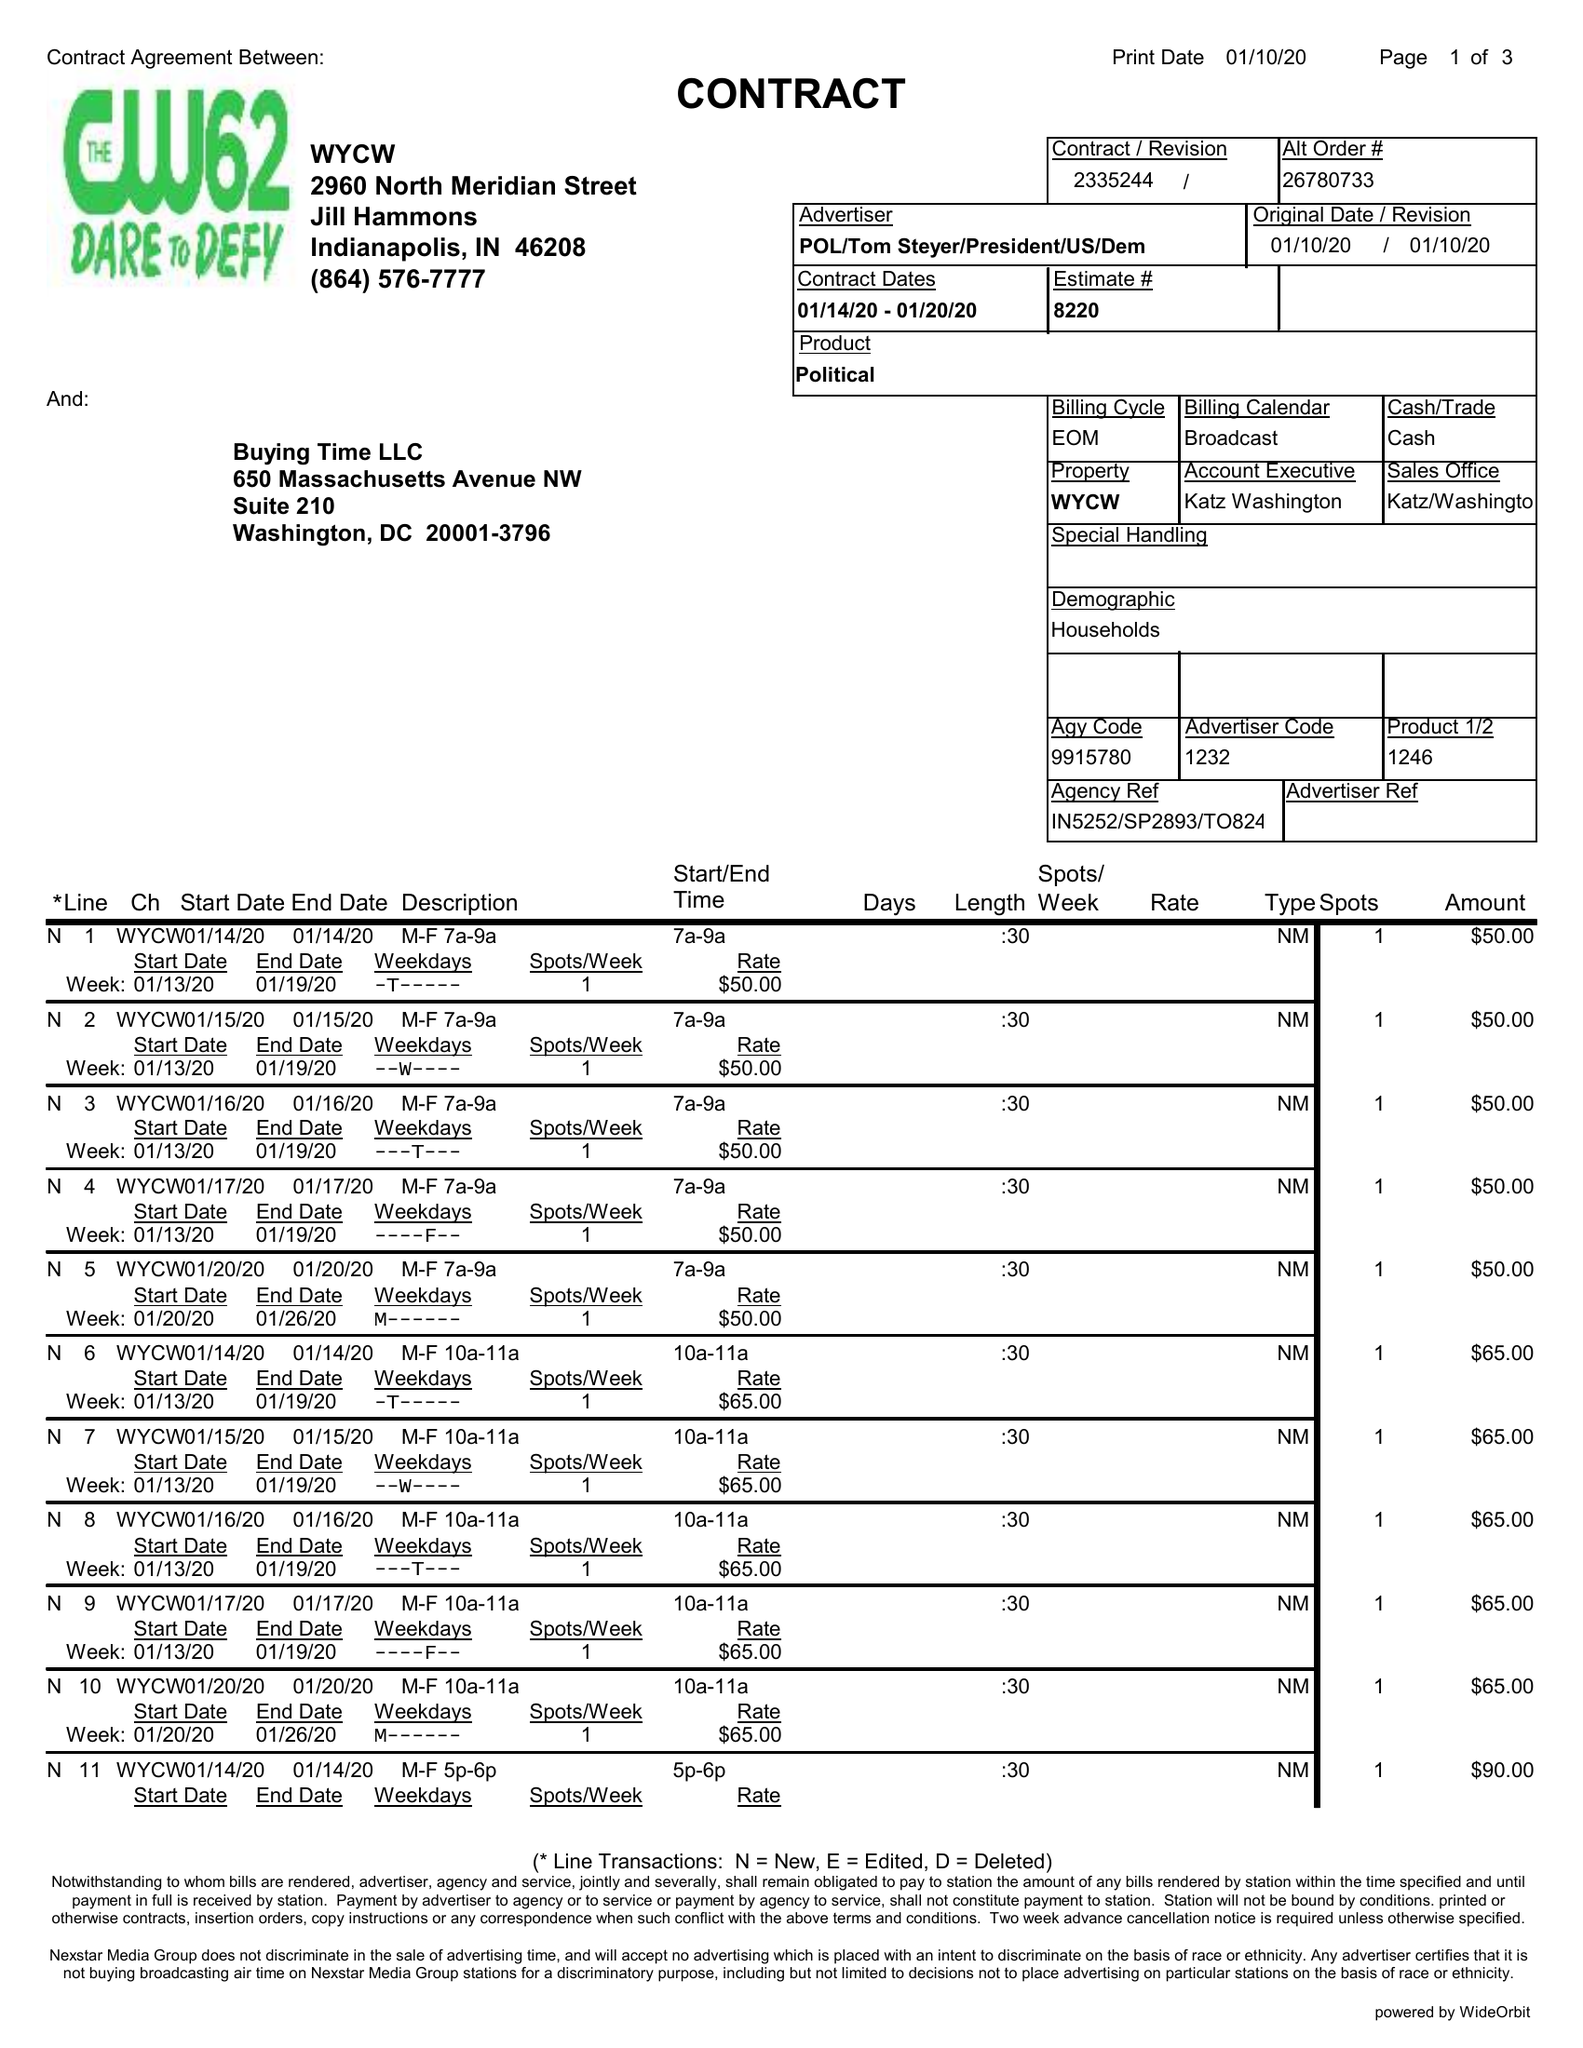What is the value for the advertiser?
Answer the question using a single word or phrase. POL/TOMSTEYER/PRESIDENT/US/DEM 